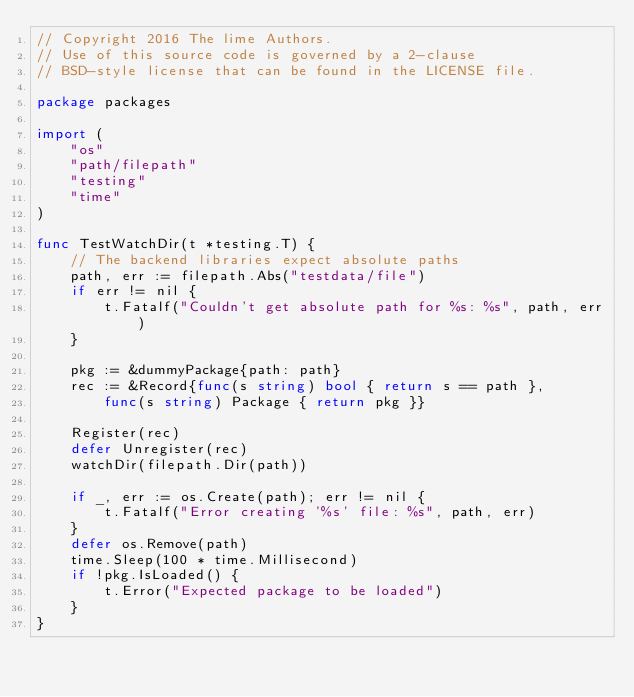Convert code to text. <code><loc_0><loc_0><loc_500><loc_500><_Go_>// Copyright 2016 The lime Authors.
// Use of this source code is governed by a 2-clause
// BSD-style license that can be found in the LICENSE file.

package packages

import (
	"os"
	"path/filepath"
	"testing"
	"time"
)

func TestWatchDir(t *testing.T) {
	// The backend libraries expect absolute paths
	path, err := filepath.Abs("testdata/file")
	if err != nil {
		t.Fatalf("Couldn't get absolute path for %s: %s", path, err)
	}

	pkg := &dummyPackage{path: path}
	rec := &Record{func(s string) bool { return s == path },
		func(s string) Package { return pkg }}

	Register(rec)
	defer Unregister(rec)
	watchDir(filepath.Dir(path))

	if _, err := os.Create(path); err != nil {
		t.Fatalf("Error creating '%s' file: %s", path, err)
	}
	defer os.Remove(path)
	time.Sleep(100 * time.Millisecond)
	if !pkg.IsLoaded() {
		t.Error("Expected package to be loaded")
	}
}
</code> 